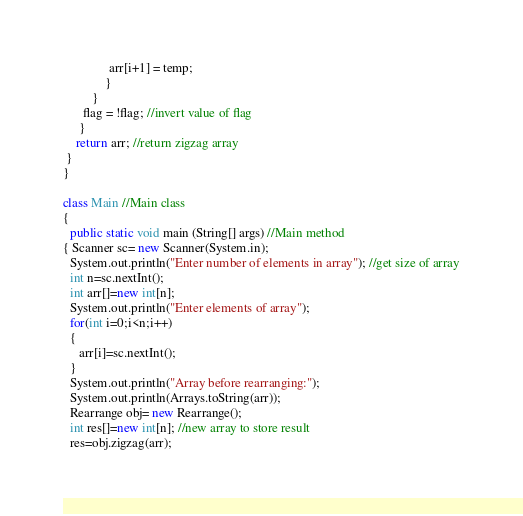<code> <loc_0><loc_0><loc_500><loc_500><_Java_>              arr[i+1] = temp;
             }
         }
      flag = !flag; //invert value of flag
     }
    return arr; //return zigzag array
 }
}

class Main //Main class
{
  public static void main (String[] args) //Main method
{ Scanner sc= new Scanner(System.in);
  System.out.println("Enter number of elements in array"); //get size of array
  int n=sc.nextInt();
  int arr[]=new int[n];
  System.out.println("Enter elements of array");
  for(int i=0;i<n;i++)
  {
     arr[i]=sc.nextInt();
  }
  System.out.println("Array before rearranging:");
  System.out.println(Arrays.toString(arr));
  Rearrange obj= new Rearrange();
  int res[]=new int[n]; //new array to store result
  res=obj.zigzag(arr);</code> 